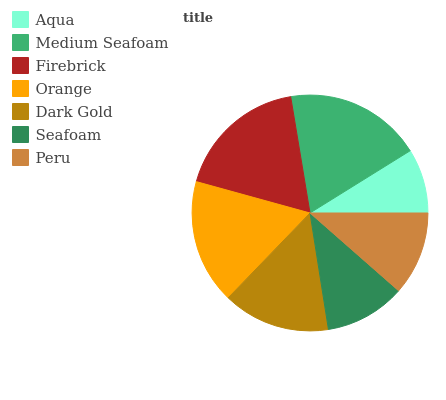Is Aqua the minimum?
Answer yes or no. Yes. Is Medium Seafoam the maximum?
Answer yes or no. Yes. Is Firebrick the minimum?
Answer yes or no. No. Is Firebrick the maximum?
Answer yes or no. No. Is Medium Seafoam greater than Firebrick?
Answer yes or no. Yes. Is Firebrick less than Medium Seafoam?
Answer yes or no. Yes. Is Firebrick greater than Medium Seafoam?
Answer yes or no. No. Is Medium Seafoam less than Firebrick?
Answer yes or no. No. Is Dark Gold the high median?
Answer yes or no. Yes. Is Dark Gold the low median?
Answer yes or no. Yes. Is Seafoam the high median?
Answer yes or no. No. Is Peru the low median?
Answer yes or no. No. 